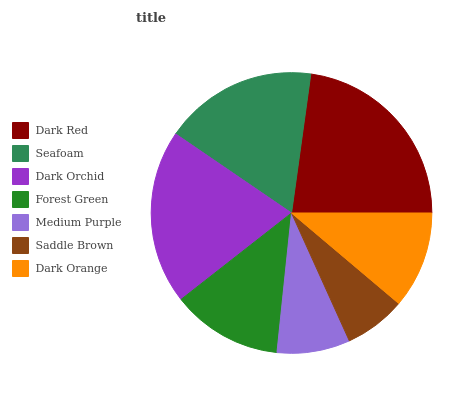Is Saddle Brown the minimum?
Answer yes or no. Yes. Is Dark Red the maximum?
Answer yes or no. Yes. Is Seafoam the minimum?
Answer yes or no. No. Is Seafoam the maximum?
Answer yes or no. No. Is Dark Red greater than Seafoam?
Answer yes or no. Yes. Is Seafoam less than Dark Red?
Answer yes or no. Yes. Is Seafoam greater than Dark Red?
Answer yes or no. No. Is Dark Red less than Seafoam?
Answer yes or no. No. Is Forest Green the high median?
Answer yes or no. Yes. Is Forest Green the low median?
Answer yes or no. Yes. Is Seafoam the high median?
Answer yes or no. No. Is Medium Purple the low median?
Answer yes or no. No. 